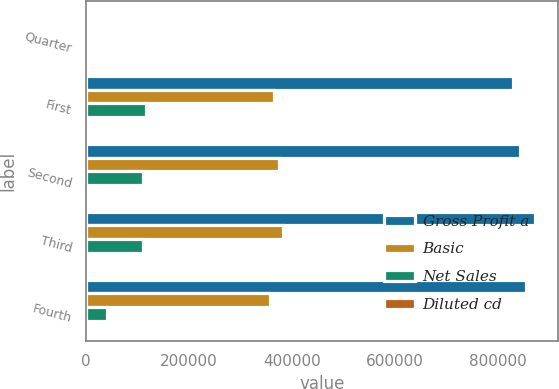Convert chart. <chart><loc_0><loc_0><loc_500><loc_500><stacked_bar_chart><ecel><fcel>Quarter<fcel>First<fcel>Second<fcel>Third<fcel>Fourth<nl><fcel>Gross Profit a<fcel>2017<fcel>828293<fcel>842861<fcel>872940<fcel>854625<nl><fcel>Basic<fcel>2017<fcel>364666<fcel>374589<fcel>382056<fcel>357690<nl><fcel>Net Sales<fcel>2017<fcel>115764<fcel>109795<fcel>110261<fcel>40155<nl><fcel>Diluted cd<fcel>2017<fcel>1.46<fcel>1.39<fcel>1.39<fcel>0.51<nl></chart> 